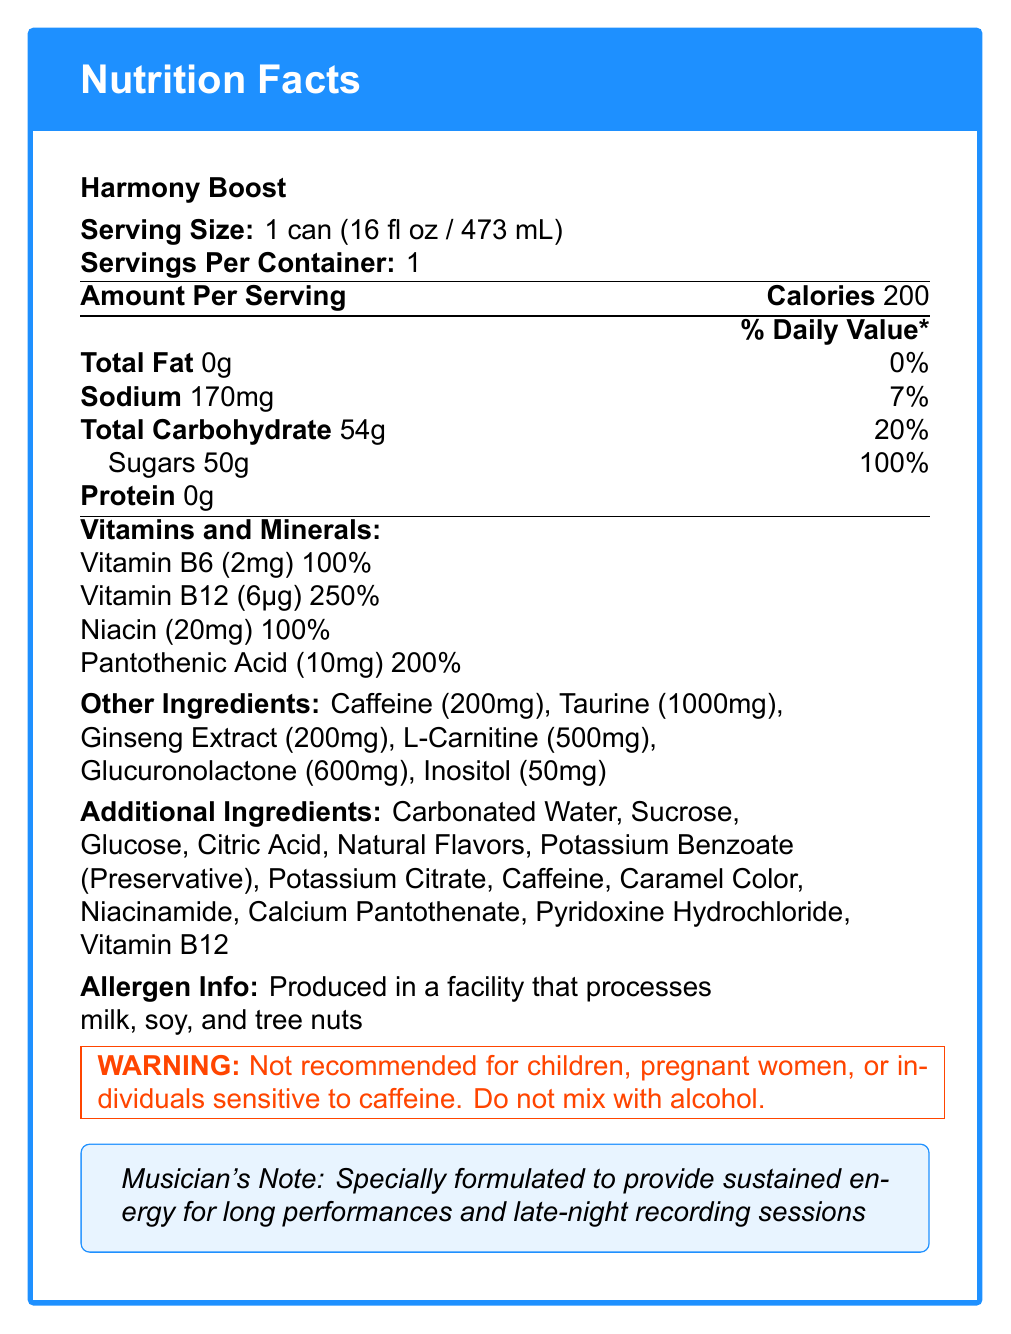What is the serving size of Harmony Boost? The serving size is stated directly at the top of the Nutrition Facts Label.
Answer: 1 can (16 fl oz / 473mL) How many calories are there per serving? The calories per serving are listed right below the serving size information.
Answer: 200 calories What percentage of the daily value of sugars does one serving of Harmony Boost provide? The daily value percentage for sugars is provided directly next to the sugars amount.
Answer: 100% How much sodium does one serving contain? The sodium content is listed under the nutritional information section.
Answer: 170mg What are the main ingredients listed in Harmony Boost aside from vitamins and minerals? These ingredients are listed under the "Additional Ingredients" section.
Answer: Carbonated Water, Sucrose, Glucose, Citric Acid, Natural Flavors, Potassium Benzoate, Potassium Citrate, Caffeine, Caramel Color, Niacinamide, Calcium Pantothenate, Pyridoxine Hydrochloride, Vitamin B12 How much Vitamin B12 is in one serving? The amount of Vitamin B12 is listed in the vitamins and minerals section.
Answer: 6μg Does this energy drink contain any fats? The total fat content is listed as 0g, indicating no fats present.
Answer: No For whom is this energy drink not recommended? A. Teenagers B. Pregnant women C. Children D. Elderly people The warning clearly states it's not recommended for children and pregnant women.
Answer: B. Pregnant women What ingredient is present in the highest amount after carbonated water? A. Sucrose B. Glucose C. Caffeine D. Taurine Sucrose is listed right after Carbonated Water in the additional ingredients section, implying it is in the second highest quantity.
Answer: A. Sucrose Is Harmony Boost produced in a facility that processes allergens? The allergen info states it is produced in a facility that processes milk, soy, and tree nuts.
Answer: Yes Based on this label, what is the main purpose of Harmony Boost for musicians? The musician's note highlights this specific purpose of the energy drink.
Answer: To provide sustained energy for long performances and late-night recording sessions Can the exact amount of caffeine in Harmony Boost be determined from this document? The document clearly states that there are 200mg of caffeine in one serving.
Answer: Yes How much taurine is in Harmony Boost? The amount of taurine is listed in the "Other Ingredients" section.
Answer: 1000mg What are the possible health risks associated with consuming Harmony Boost? A. High sodium levels B. High sugar content C. Presence of allergens D. High caffeine content The warning indicates potential risks for individuals sensitive to caffeine, and the sugar content is 100% of the daily value.
Answer: B. High sugar content and D. High caffeine content Summarize the main nutritional attributes and additional information provided about Harmony Boost. The summary captures detailed information about the nutritional content, intended use, key ingredients, allergen info, and warnings as presented in the document.
Answer: Harmony Boost is an energy drink intended for musicians, containing no fats or proteins but 200 calories and 54g of carbohydrates per serving. It includes a high sugar content (50g), significant amounts of Vitamin B6, B12, Niacin, and Pantothenic Acid, and various energy-enhancing ingredients like caffeine, taurine, and ginseng extract. The drink is produced in a facility that processes common allergens and carries warnings for children, pregnant women, and mixing with alcohol. What is the effect of carbonated water on the drink's nutritional value? The document provides a list of ingredients but does not explain their individual effects on nutritional value.
Answer: Cannot be determined 